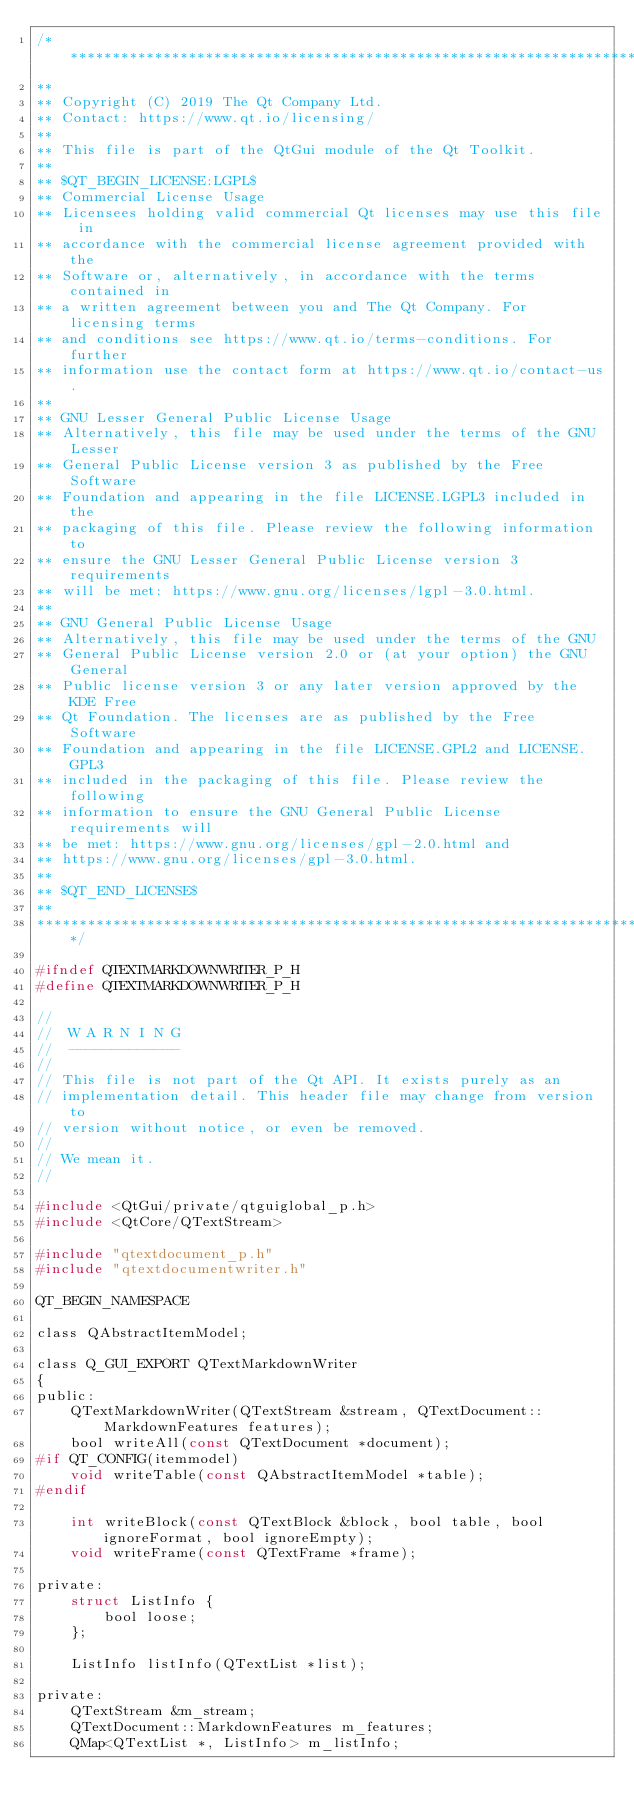<code> <loc_0><loc_0><loc_500><loc_500><_C_>/****************************************************************************
**
** Copyright (C) 2019 The Qt Company Ltd.
** Contact: https://www.qt.io/licensing/
**
** This file is part of the QtGui module of the Qt Toolkit.
**
** $QT_BEGIN_LICENSE:LGPL$
** Commercial License Usage
** Licensees holding valid commercial Qt licenses may use this file in
** accordance with the commercial license agreement provided with the
** Software or, alternatively, in accordance with the terms contained in
** a written agreement between you and The Qt Company. For licensing terms
** and conditions see https://www.qt.io/terms-conditions. For further
** information use the contact form at https://www.qt.io/contact-us.
**
** GNU Lesser General Public License Usage
** Alternatively, this file may be used under the terms of the GNU Lesser
** General Public License version 3 as published by the Free Software
** Foundation and appearing in the file LICENSE.LGPL3 included in the
** packaging of this file. Please review the following information to
** ensure the GNU Lesser General Public License version 3 requirements
** will be met: https://www.gnu.org/licenses/lgpl-3.0.html.
**
** GNU General Public License Usage
** Alternatively, this file may be used under the terms of the GNU
** General Public License version 2.0 or (at your option) the GNU General
** Public license version 3 or any later version approved by the KDE Free
** Qt Foundation. The licenses are as published by the Free Software
** Foundation and appearing in the file LICENSE.GPL2 and LICENSE.GPL3
** included in the packaging of this file. Please review the following
** information to ensure the GNU General Public License requirements will
** be met: https://www.gnu.org/licenses/gpl-2.0.html and
** https://www.gnu.org/licenses/gpl-3.0.html.
**
** $QT_END_LICENSE$
**
****************************************************************************/

#ifndef QTEXTMARKDOWNWRITER_P_H
#define QTEXTMARKDOWNWRITER_P_H

//
//  W A R N I N G
//  -------------
//
// This file is not part of the Qt API. It exists purely as an
// implementation detail. This header file may change from version to
// version without notice, or even be removed.
//
// We mean it.
//

#include <QtGui/private/qtguiglobal_p.h>
#include <QtCore/QTextStream>

#include "qtextdocument_p.h"
#include "qtextdocumentwriter.h"

QT_BEGIN_NAMESPACE

class QAbstractItemModel;

class Q_GUI_EXPORT QTextMarkdownWriter
{
public:
    QTextMarkdownWriter(QTextStream &stream, QTextDocument::MarkdownFeatures features);
    bool writeAll(const QTextDocument *document);
#if QT_CONFIG(itemmodel)
    void writeTable(const QAbstractItemModel *table);
#endif

    int writeBlock(const QTextBlock &block, bool table, bool ignoreFormat, bool ignoreEmpty);
    void writeFrame(const QTextFrame *frame);

private:
    struct ListInfo {
        bool loose;
    };

    ListInfo listInfo(QTextList *list);

private:
    QTextStream &m_stream;
    QTextDocument::MarkdownFeatures m_features;
    QMap<QTextList *, ListInfo> m_listInfo;</code> 